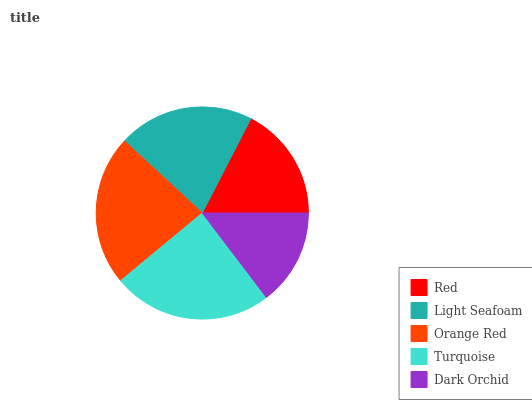Is Dark Orchid the minimum?
Answer yes or no. Yes. Is Turquoise the maximum?
Answer yes or no. Yes. Is Light Seafoam the minimum?
Answer yes or no. No. Is Light Seafoam the maximum?
Answer yes or no. No. Is Light Seafoam greater than Red?
Answer yes or no. Yes. Is Red less than Light Seafoam?
Answer yes or no. Yes. Is Red greater than Light Seafoam?
Answer yes or no. No. Is Light Seafoam less than Red?
Answer yes or no. No. Is Light Seafoam the high median?
Answer yes or no. Yes. Is Light Seafoam the low median?
Answer yes or no. Yes. Is Turquoise the high median?
Answer yes or no. No. Is Dark Orchid the low median?
Answer yes or no. No. 